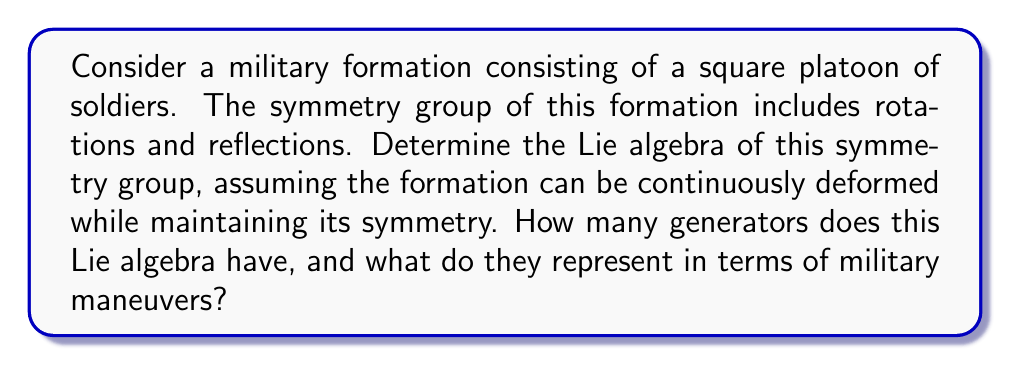What is the answer to this math problem? To solve this problem, we need to follow these steps:

1) First, identify the symmetry group of the square formation. This is the dihedral group $D_4$, which includes rotations by multiples of 90° and reflections across the diagonals and midlines.

2) However, we're interested in the continuous symmetries for the Lie algebra. The discrete symmetries (reflections) don't contribute to the Lie algebra. We're left with the continuous rotations, which form the subgroup $SO(2)$.

3) The Lie algebra of $SO(2)$ is $\mathfrak{so}(2)$, which is one-dimensional. It's generated by a single element, which we can represent as:

   $$J = \begin{pmatrix} 0 & -1 \\ 1 & 0 \end{pmatrix}$$

4) This generator $J$ represents an infinitesimal rotation. In military terms, it corresponds to a continuous wheeling maneuver, where the entire formation rotates as a unit.

5) The Lie bracket operation for this algebra is trivial, as there's only one generator:

   $$[J,J] = 0$$

6) In terms of military maneuvers, this Lie algebra represents the capability of the formation to perform continuous rotations while maintaining its square shape. The single generator corresponds to the rate of rotation of the formation.

[asy]
unitsize(1cm);
pair A = (0,0), B = (2,0), C = (2,2), D = (0,2);
draw(A--B--C--D--cycle);
draw(Arc(A,0.5,0,90), arrow=Arrow());
label("$J$", (0.5,0.5), NE);
[/asy]

The diagram shows the square formation with the rotation generator $J$ represented by a curved arrow.
Answer: The Lie algebra of the symmetry group of the square military formation is $\mathfrak{so}(2)$, which has one generator. This generator represents the continuous rotation (wheeling maneuver) of the entire formation. 